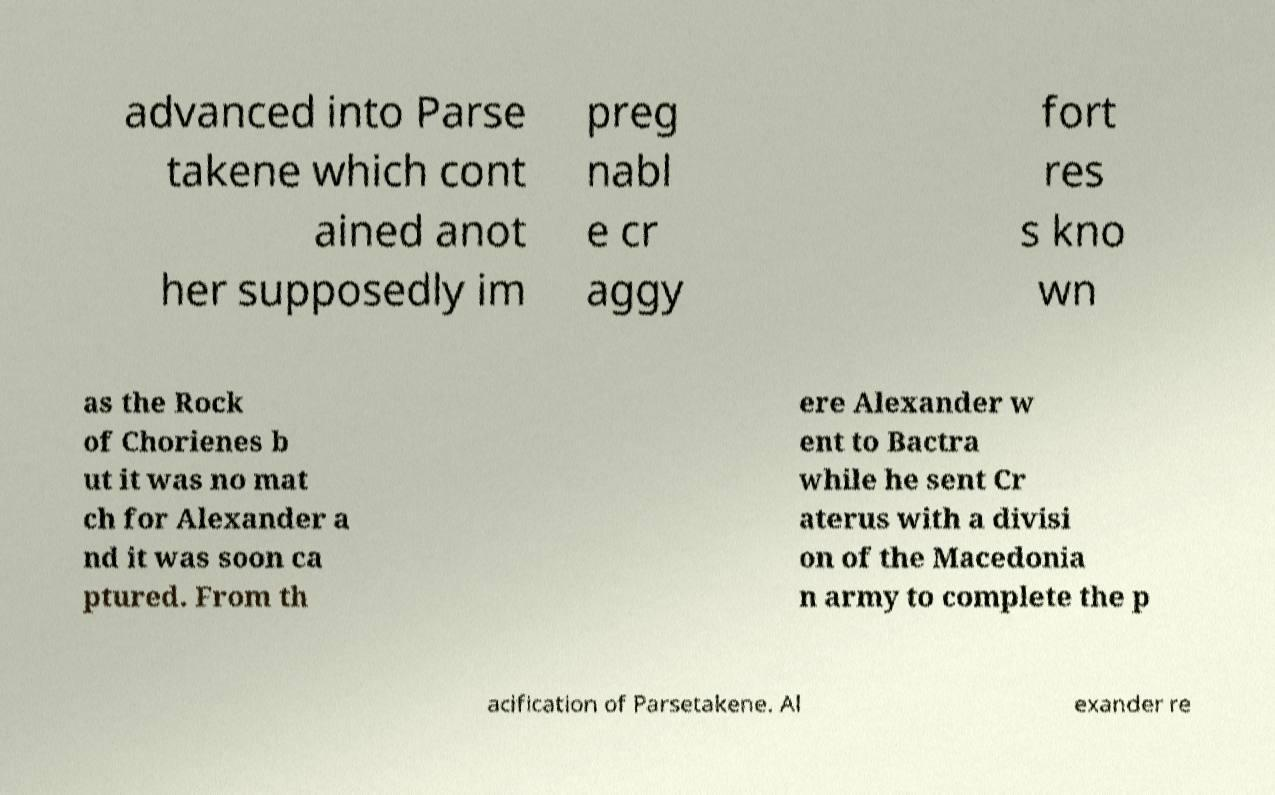What messages or text are displayed in this image? I need them in a readable, typed format. advanced into Parse takene which cont ained anot her supposedly im preg nabl e cr aggy fort res s kno wn as the Rock of Chorienes b ut it was no mat ch for Alexander a nd it was soon ca ptured. From th ere Alexander w ent to Bactra while he sent Cr aterus with a divisi on of the Macedonia n army to complete the p acification of Parsetakene. Al exander re 